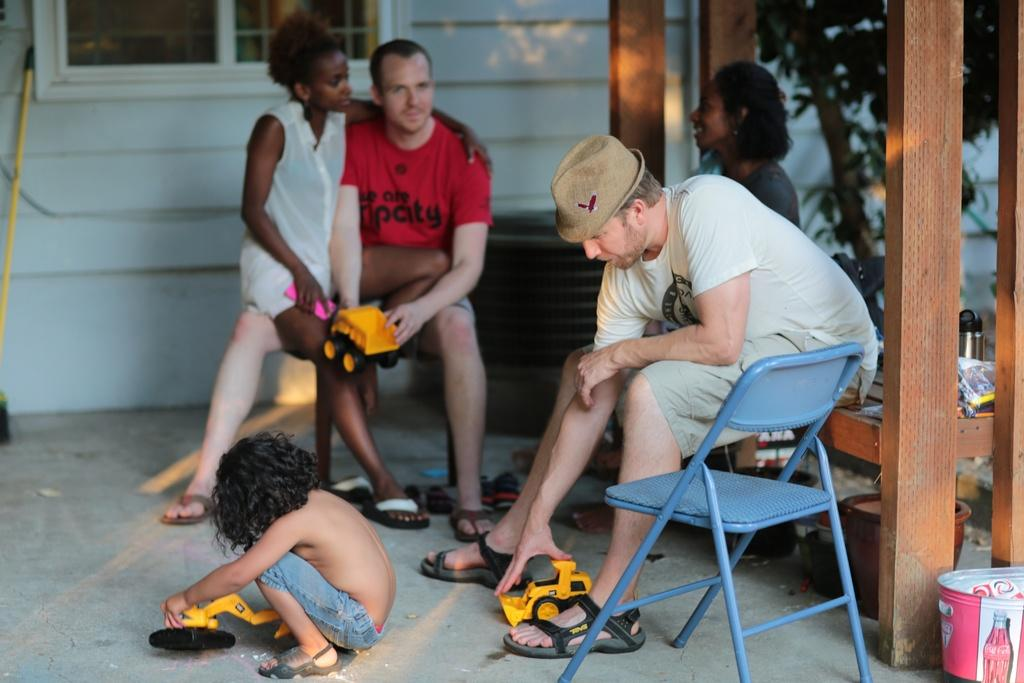What type of plant can be seen in the image? There is a tree in the image. What is the color of the wall visible in the image? There is a white color wall in the image. What architectural feature is present in the image? There is a window in the image. What type of furniture is in the image? There is a chair in the image. What are the people in the image doing? There are people sitting in the image. What type of jam is being spread on the record in the image? There is no jam or record present in the image. What color is the crib in the image? There is no crib present in the image. 